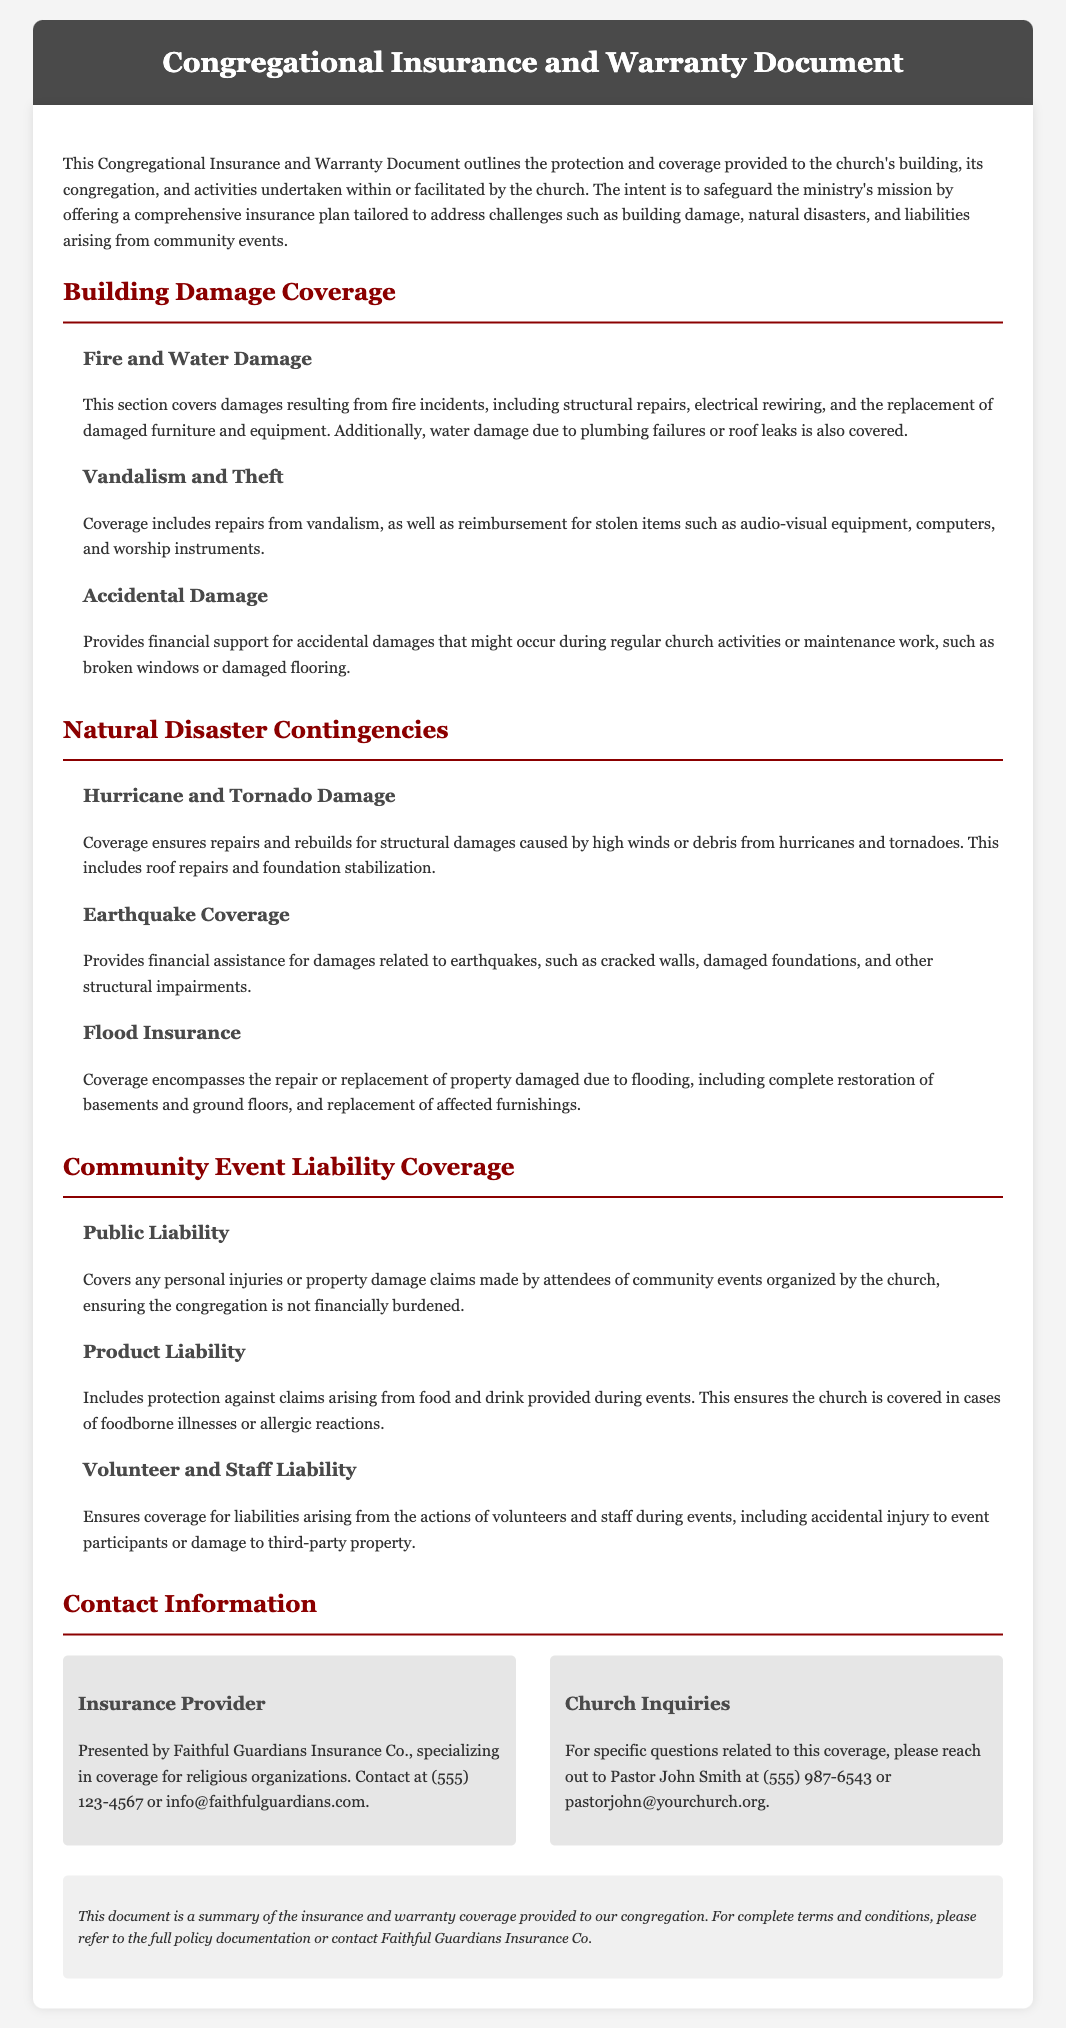what company presents the insurance? The document states that the insurance is presented by Faithful Guardians Insurance Co., specializing in coverage for religious organizations.
Answer: Faithful Guardians Insurance Co what aspect of building damage does the policy cover related to accidents? The document mentions that the policy provides financial support for accidental damages that might occur during regular church activities.
Answer: Accidental Damage how does the document ensure protection against natural disasters? It lists specific coverages such as hurricane, tornado, earthquake, and flood insurance, providing detailed information on how damages from these events are handled.
Answer: Natural Disaster Contingencies what type of liability coverage is provided for community events? It includes public liability, product liability, and volunteer and staff liability to protect against various claims.
Answer: Community Event Liability Coverage what is the contact number for church inquiries? The document provides a specific contact number for inquiries related to this coverage. The stated number is (555) 987-6543.
Answer: (555) 987-6543 what would be covered under flood insurance? The document specifies that coverage encompasses the repair or replacement of property damaged due to flooding, including restoration of basements and ground floors.
Answer: Repair or replacement of property damaged due to flooding which event-related claim includes foodborne illnesses? The document states that product liability covers claims arising from food and drink provided during events, including foodborne illnesses.
Answer: Product Liability what type of damages from vandalism are covered? The document states that coverage includes repairs from vandalism, reimbursement for stolen items such as audio-visual equipment, computers, and worship instruments.
Answer: Repairs from vandalism and reimbursement for stolen items 